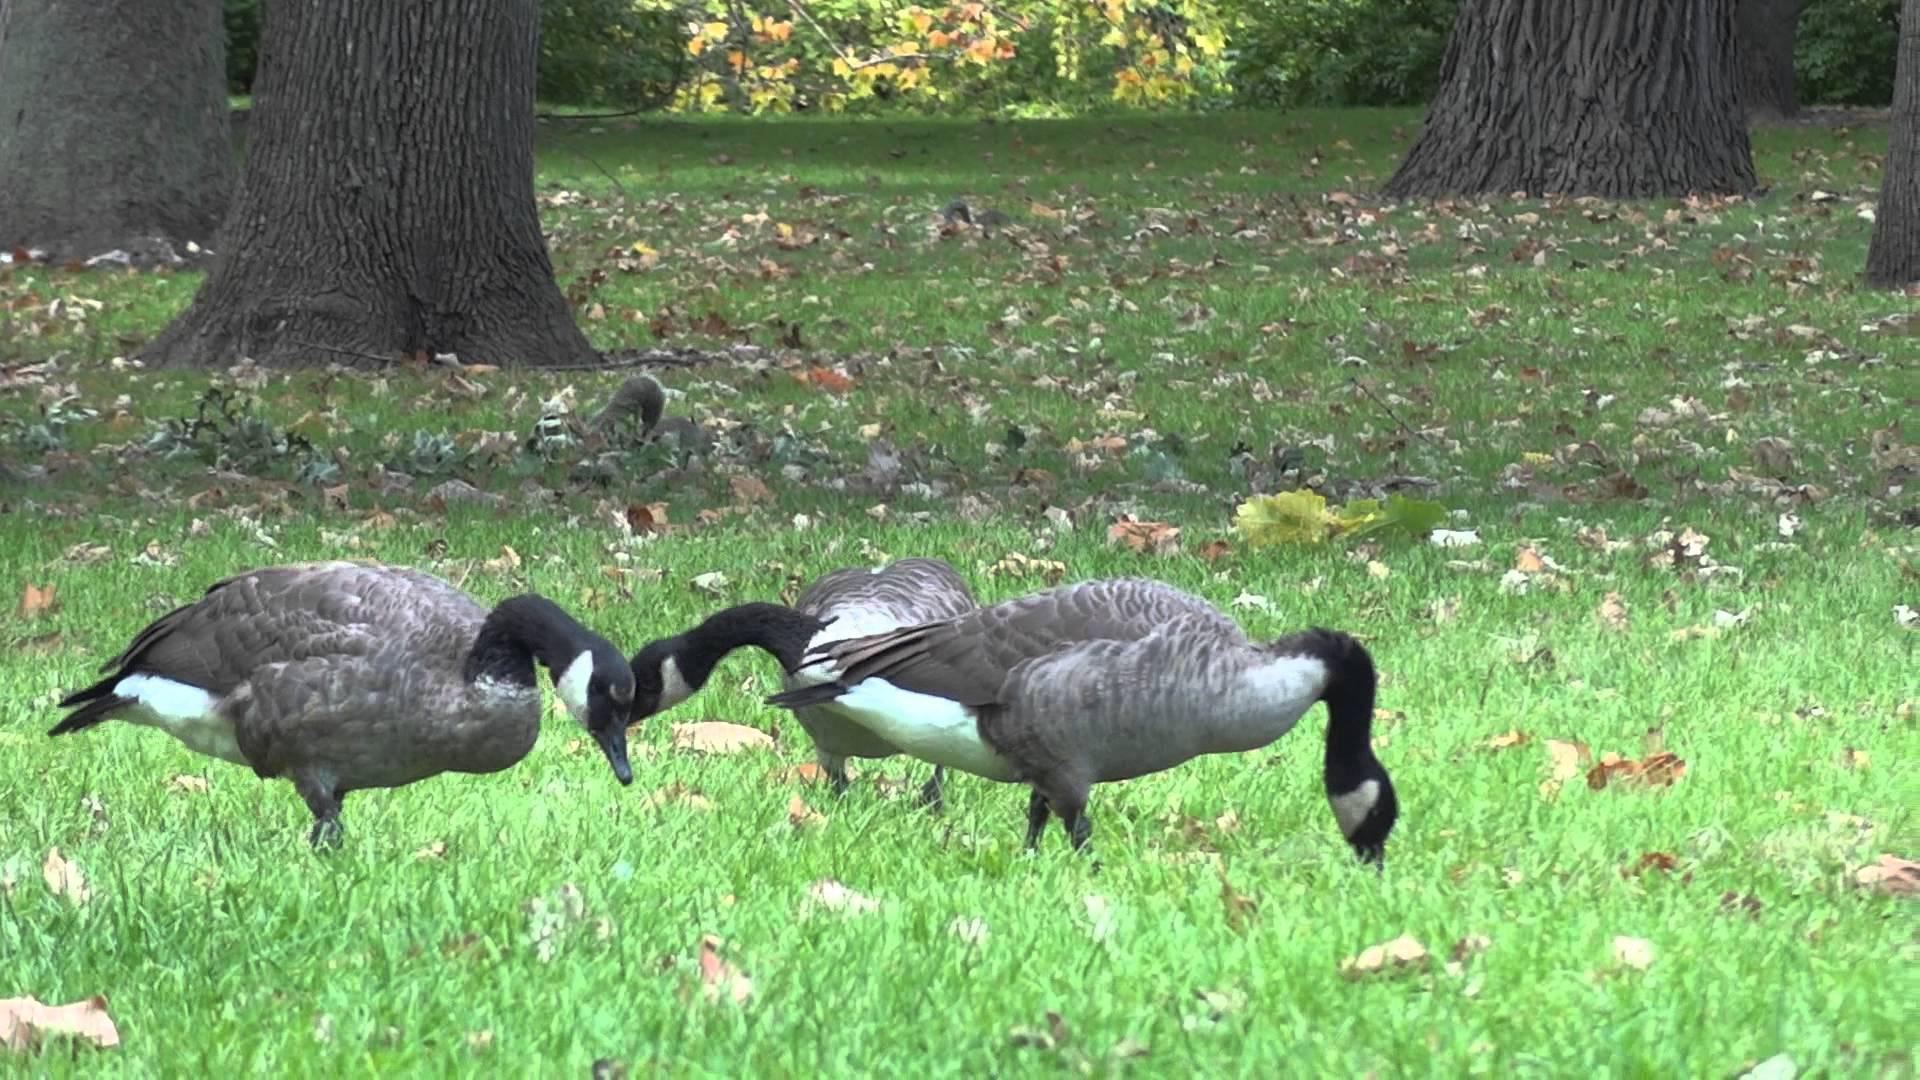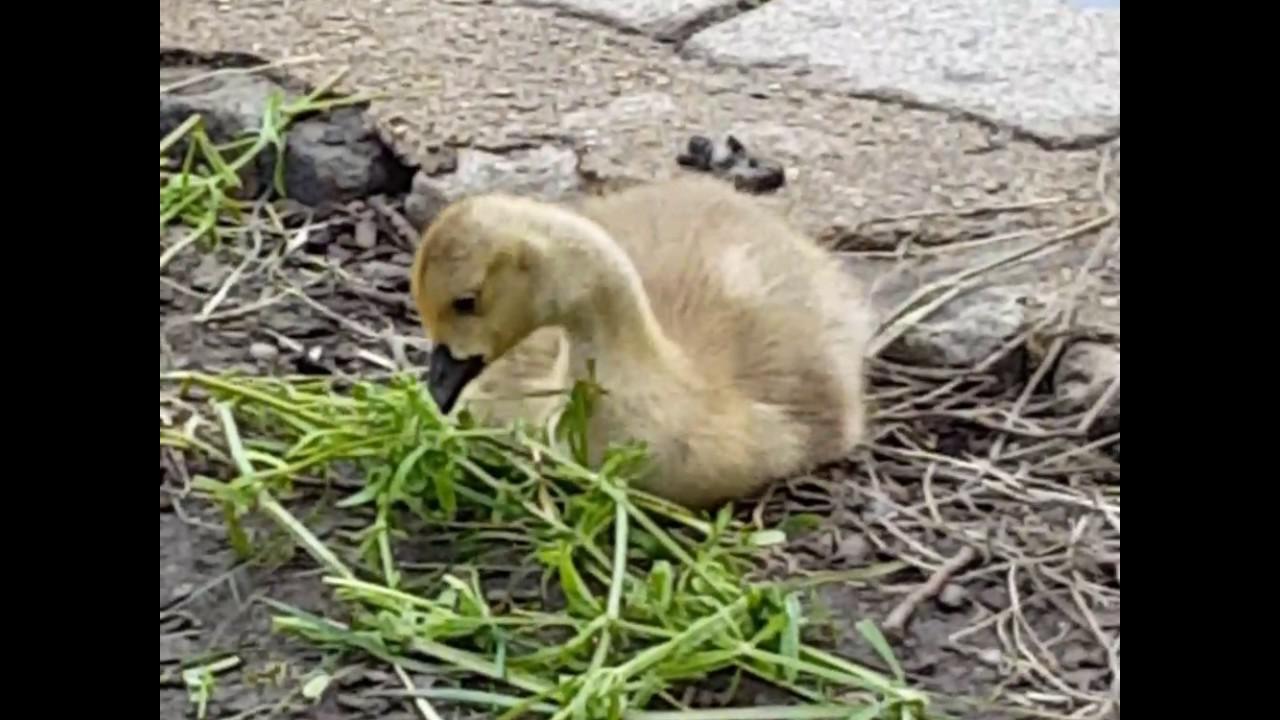The first image is the image on the left, the second image is the image on the right. Given the left and right images, does the statement "The duck in the right image has its beak on the ground." hold true? Answer yes or no. No. The first image is the image on the left, the second image is the image on the right. Examine the images to the left and right. Is the description "Each image contains one black-necked goose, and each goose has its neck bent so its beak points downward." accurate? Answer yes or no. No. 